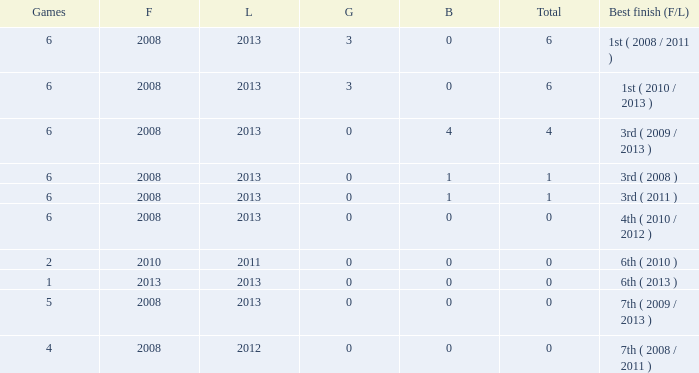How many games are associated with over 0 golds and a first year before 2008? None. 